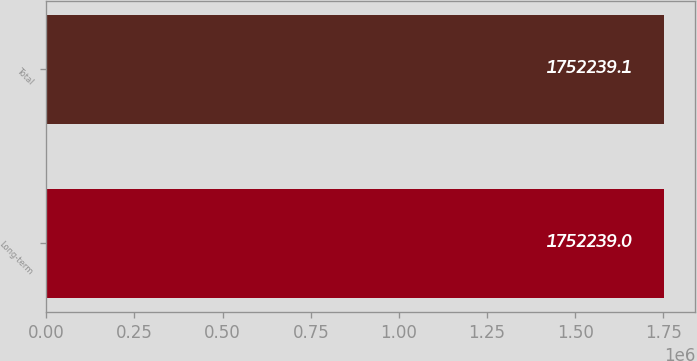<chart> <loc_0><loc_0><loc_500><loc_500><bar_chart><fcel>Long-term<fcel>Total<nl><fcel>1.75224e+06<fcel>1.75224e+06<nl></chart> 